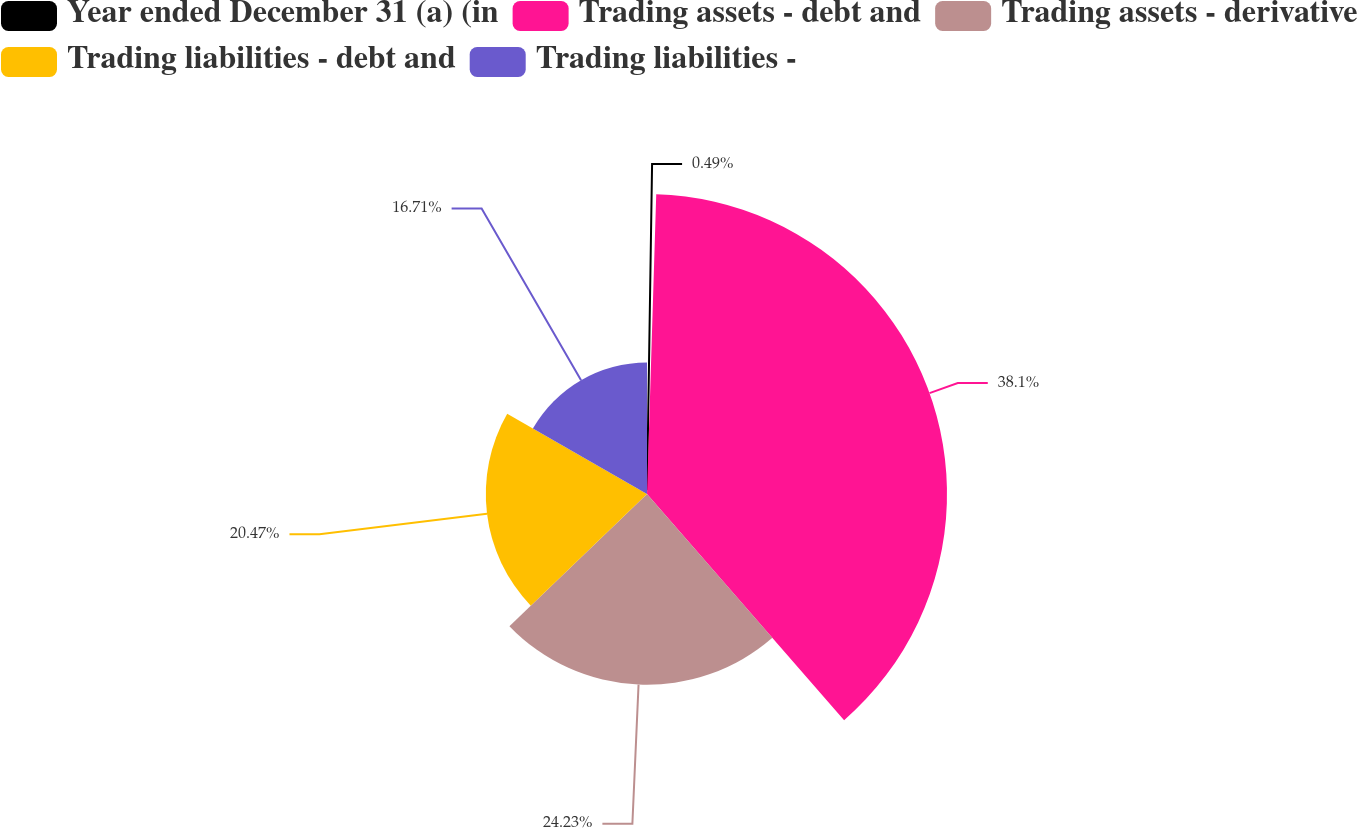Convert chart to OTSL. <chart><loc_0><loc_0><loc_500><loc_500><pie_chart><fcel>Year ended December 31 (a) (in<fcel>Trading assets - debt and<fcel>Trading assets - derivative<fcel>Trading liabilities - debt and<fcel>Trading liabilities -<nl><fcel>0.49%<fcel>38.1%<fcel>24.23%<fcel>20.47%<fcel>16.71%<nl></chart> 